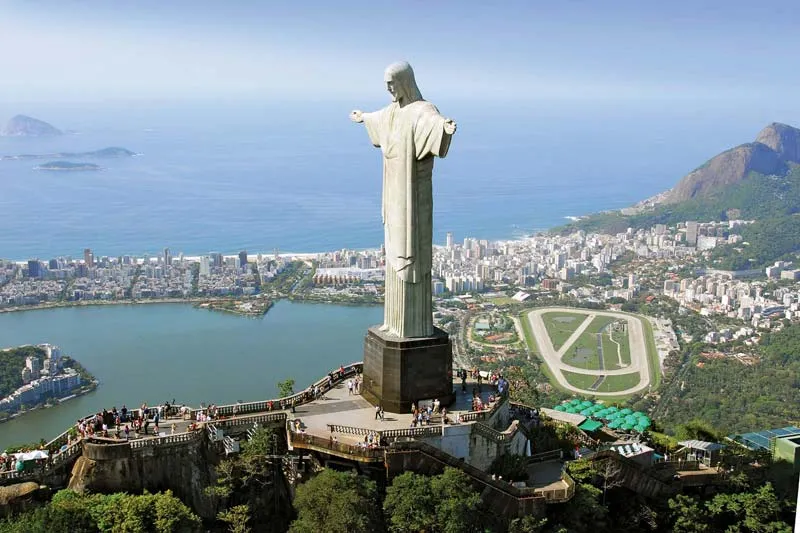Describe a typical day at the Christ the Redeemer viewing platform. On a typical day at the Christ the Redeemer viewing platform, visitors start arriving early to catch the breathtaking sunrise and to avoid the midday crowds. The air is filled with excitement and the buzz of various languages as tourists from around the globe gather to witness the iconic statue up close. People can be seen capturing photographs, some posing with their own arms outstretched to mimic the statue's famous pose. The viewing platform offers panoramic views of Rio de Janeiro, with the lush Tijuca Forest, sprawling cityscape, and sparkling ocean below, providing a stunning backdrop for countless memorable moments. Throughout the day, the platform remains lively with guides explaining the history and significance of the monument, souvenir vendors offering keepsakes, and the occasional performances by local musicians adding a cultural touch to the visitors' experience. 